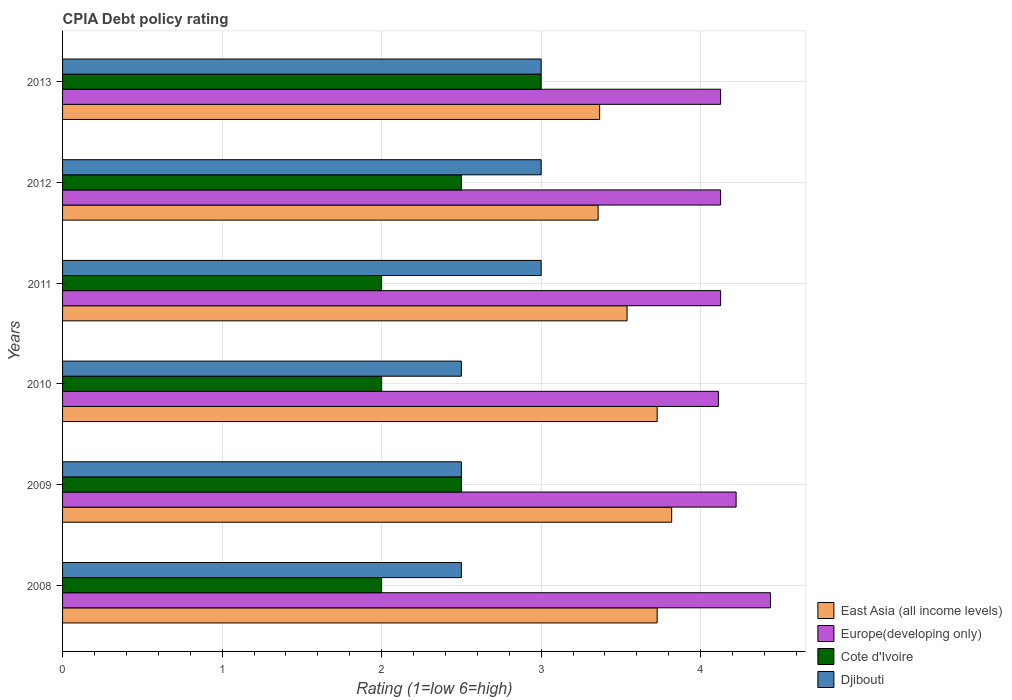How many different coloured bars are there?
Offer a very short reply. 4. Are the number of bars per tick equal to the number of legend labels?
Provide a short and direct response. Yes. How many bars are there on the 5th tick from the bottom?
Provide a short and direct response. 4. What is the label of the 5th group of bars from the top?
Offer a terse response. 2009. In how many cases, is the number of bars for a given year not equal to the number of legend labels?
Keep it short and to the point. 0. What is the CPIA rating in Europe(developing only) in 2009?
Your answer should be very brief. 4.22. Across all years, what is the maximum CPIA rating in East Asia (all income levels)?
Ensure brevity in your answer.  3.82. Across all years, what is the minimum CPIA rating in East Asia (all income levels)?
Provide a short and direct response. 3.36. In which year was the CPIA rating in Djibouti maximum?
Your answer should be very brief. 2011. What is the average CPIA rating in Europe(developing only) per year?
Offer a very short reply. 4.19. In the year 2009, what is the difference between the CPIA rating in Djibouti and CPIA rating in Europe(developing only)?
Provide a short and direct response. -1.72. In how many years, is the CPIA rating in Djibouti greater than 3.6 ?
Give a very brief answer. 0. What is the ratio of the CPIA rating in East Asia (all income levels) in 2009 to that in 2012?
Your answer should be very brief. 1.14. Is the CPIA rating in Europe(developing only) in 2008 less than that in 2013?
Your answer should be compact. No. Is the difference between the CPIA rating in Djibouti in 2012 and 2013 greater than the difference between the CPIA rating in Europe(developing only) in 2012 and 2013?
Provide a succinct answer. No. What is the difference between the highest and the second highest CPIA rating in Cote d'Ivoire?
Make the answer very short. 0.5. What is the difference between the highest and the lowest CPIA rating in East Asia (all income levels)?
Give a very brief answer. 0.46. Is the sum of the CPIA rating in Cote d'Ivoire in 2011 and 2013 greater than the maximum CPIA rating in Djibouti across all years?
Provide a succinct answer. Yes. Is it the case that in every year, the sum of the CPIA rating in Europe(developing only) and CPIA rating in East Asia (all income levels) is greater than the sum of CPIA rating in Cote d'Ivoire and CPIA rating in Djibouti?
Keep it short and to the point. No. What does the 3rd bar from the top in 2013 represents?
Your answer should be very brief. Europe(developing only). What does the 4th bar from the bottom in 2010 represents?
Your answer should be very brief. Djibouti. Are the values on the major ticks of X-axis written in scientific E-notation?
Offer a very short reply. No. Does the graph contain grids?
Offer a terse response. Yes. Where does the legend appear in the graph?
Your answer should be compact. Bottom right. How are the legend labels stacked?
Make the answer very short. Vertical. What is the title of the graph?
Your answer should be compact. CPIA Debt policy rating. Does "Mali" appear as one of the legend labels in the graph?
Provide a succinct answer. No. What is the label or title of the X-axis?
Your answer should be very brief. Rating (1=low 6=high). What is the label or title of the Y-axis?
Make the answer very short. Years. What is the Rating (1=low 6=high) in East Asia (all income levels) in 2008?
Offer a terse response. 3.73. What is the Rating (1=low 6=high) in Europe(developing only) in 2008?
Give a very brief answer. 4.44. What is the Rating (1=low 6=high) of Cote d'Ivoire in 2008?
Ensure brevity in your answer.  2. What is the Rating (1=low 6=high) of Djibouti in 2008?
Ensure brevity in your answer.  2.5. What is the Rating (1=low 6=high) of East Asia (all income levels) in 2009?
Make the answer very short. 3.82. What is the Rating (1=low 6=high) in Europe(developing only) in 2009?
Give a very brief answer. 4.22. What is the Rating (1=low 6=high) of Djibouti in 2009?
Provide a short and direct response. 2.5. What is the Rating (1=low 6=high) of East Asia (all income levels) in 2010?
Your answer should be very brief. 3.73. What is the Rating (1=low 6=high) in Europe(developing only) in 2010?
Provide a short and direct response. 4.11. What is the Rating (1=low 6=high) in East Asia (all income levels) in 2011?
Offer a very short reply. 3.54. What is the Rating (1=low 6=high) of Europe(developing only) in 2011?
Offer a terse response. 4.12. What is the Rating (1=low 6=high) in East Asia (all income levels) in 2012?
Your answer should be very brief. 3.36. What is the Rating (1=low 6=high) in Europe(developing only) in 2012?
Your answer should be compact. 4.12. What is the Rating (1=low 6=high) of East Asia (all income levels) in 2013?
Your answer should be compact. 3.37. What is the Rating (1=low 6=high) of Europe(developing only) in 2013?
Your answer should be compact. 4.12. Across all years, what is the maximum Rating (1=low 6=high) of East Asia (all income levels)?
Give a very brief answer. 3.82. Across all years, what is the maximum Rating (1=low 6=high) in Europe(developing only)?
Provide a short and direct response. 4.44. Across all years, what is the maximum Rating (1=low 6=high) in Cote d'Ivoire?
Provide a succinct answer. 3. Across all years, what is the maximum Rating (1=low 6=high) of Djibouti?
Your answer should be very brief. 3. Across all years, what is the minimum Rating (1=low 6=high) of East Asia (all income levels)?
Your answer should be compact. 3.36. Across all years, what is the minimum Rating (1=low 6=high) in Europe(developing only)?
Your answer should be very brief. 4.11. Across all years, what is the minimum Rating (1=low 6=high) of Cote d'Ivoire?
Your answer should be very brief. 2. Across all years, what is the minimum Rating (1=low 6=high) of Djibouti?
Provide a short and direct response. 2.5. What is the total Rating (1=low 6=high) in East Asia (all income levels) in the graph?
Offer a terse response. 21.54. What is the total Rating (1=low 6=high) in Europe(developing only) in the graph?
Ensure brevity in your answer.  25.15. What is the total Rating (1=low 6=high) of Djibouti in the graph?
Your response must be concise. 16.5. What is the difference between the Rating (1=low 6=high) of East Asia (all income levels) in 2008 and that in 2009?
Make the answer very short. -0.09. What is the difference between the Rating (1=low 6=high) in Europe(developing only) in 2008 and that in 2009?
Your response must be concise. 0.22. What is the difference between the Rating (1=low 6=high) of East Asia (all income levels) in 2008 and that in 2010?
Make the answer very short. 0. What is the difference between the Rating (1=low 6=high) of Europe(developing only) in 2008 and that in 2010?
Provide a short and direct response. 0.33. What is the difference between the Rating (1=low 6=high) in Cote d'Ivoire in 2008 and that in 2010?
Keep it short and to the point. 0. What is the difference between the Rating (1=low 6=high) in East Asia (all income levels) in 2008 and that in 2011?
Keep it short and to the point. 0.19. What is the difference between the Rating (1=low 6=high) in Europe(developing only) in 2008 and that in 2011?
Offer a very short reply. 0.31. What is the difference between the Rating (1=low 6=high) in Djibouti in 2008 and that in 2011?
Provide a succinct answer. -0.5. What is the difference between the Rating (1=low 6=high) in East Asia (all income levels) in 2008 and that in 2012?
Make the answer very short. 0.37. What is the difference between the Rating (1=low 6=high) of Europe(developing only) in 2008 and that in 2012?
Make the answer very short. 0.31. What is the difference between the Rating (1=low 6=high) of Cote d'Ivoire in 2008 and that in 2012?
Ensure brevity in your answer.  -0.5. What is the difference between the Rating (1=low 6=high) of Djibouti in 2008 and that in 2012?
Ensure brevity in your answer.  -0.5. What is the difference between the Rating (1=low 6=high) of East Asia (all income levels) in 2008 and that in 2013?
Give a very brief answer. 0.36. What is the difference between the Rating (1=low 6=high) in Europe(developing only) in 2008 and that in 2013?
Your answer should be compact. 0.31. What is the difference between the Rating (1=low 6=high) in East Asia (all income levels) in 2009 and that in 2010?
Offer a terse response. 0.09. What is the difference between the Rating (1=low 6=high) of Europe(developing only) in 2009 and that in 2010?
Offer a terse response. 0.11. What is the difference between the Rating (1=low 6=high) of Cote d'Ivoire in 2009 and that in 2010?
Your answer should be very brief. 0.5. What is the difference between the Rating (1=low 6=high) of East Asia (all income levels) in 2009 and that in 2011?
Ensure brevity in your answer.  0.28. What is the difference between the Rating (1=low 6=high) in Europe(developing only) in 2009 and that in 2011?
Ensure brevity in your answer.  0.1. What is the difference between the Rating (1=low 6=high) of East Asia (all income levels) in 2009 and that in 2012?
Provide a succinct answer. 0.46. What is the difference between the Rating (1=low 6=high) in Europe(developing only) in 2009 and that in 2012?
Ensure brevity in your answer.  0.1. What is the difference between the Rating (1=low 6=high) in Cote d'Ivoire in 2009 and that in 2012?
Offer a very short reply. 0. What is the difference between the Rating (1=low 6=high) in East Asia (all income levels) in 2009 and that in 2013?
Give a very brief answer. 0.45. What is the difference between the Rating (1=low 6=high) in Europe(developing only) in 2009 and that in 2013?
Provide a short and direct response. 0.1. What is the difference between the Rating (1=low 6=high) of East Asia (all income levels) in 2010 and that in 2011?
Make the answer very short. 0.19. What is the difference between the Rating (1=low 6=high) of Europe(developing only) in 2010 and that in 2011?
Provide a succinct answer. -0.01. What is the difference between the Rating (1=low 6=high) of Cote d'Ivoire in 2010 and that in 2011?
Keep it short and to the point. 0. What is the difference between the Rating (1=low 6=high) of Djibouti in 2010 and that in 2011?
Your answer should be very brief. -0.5. What is the difference between the Rating (1=low 6=high) of East Asia (all income levels) in 2010 and that in 2012?
Your response must be concise. 0.37. What is the difference between the Rating (1=low 6=high) of Europe(developing only) in 2010 and that in 2012?
Your answer should be very brief. -0.01. What is the difference between the Rating (1=low 6=high) in Cote d'Ivoire in 2010 and that in 2012?
Provide a short and direct response. -0.5. What is the difference between the Rating (1=low 6=high) of Djibouti in 2010 and that in 2012?
Ensure brevity in your answer.  -0.5. What is the difference between the Rating (1=low 6=high) in East Asia (all income levels) in 2010 and that in 2013?
Offer a terse response. 0.36. What is the difference between the Rating (1=low 6=high) in Europe(developing only) in 2010 and that in 2013?
Ensure brevity in your answer.  -0.01. What is the difference between the Rating (1=low 6=high) in Cote d'Ivoire in 2010 and that in 2013?
Offer a terse response. -1. What is the difference between the Rating (1=low 6=high) of East Asia (all income levels) in 2011 and that in 2012?
Provide a succinct answer. 0.18. What is the difference between the Rating (1=low 6=high) of Djibouti in 2011 and that in 2012?
Give a very brief answer. 0. What is the difference between the Rating (1=low 6=high) of East Asia (all income levels) in 2011 and that in 2013?
Offer a terse response. 0.17. What is the difference between the Rating (1=low 6=high) of Europe(developing only) in 2011 and that in 2013?
Offer a very short reply. 0. What is the difference between the Rating (1=low 6=high) of East Asia (all income levels) in 2012 and that in 2013?
Offer a terse response. -0.01. What is the difference between the Rating (1=low 6=high) in East Asia (all income levels) in 2008 and the Rating (1=low 6=high) in Europe(developing only) in 2009?
Provide a succinct answer. -0.49. What is the difference between the Rating (1=low 6=high) in East Asia (all income levels) in 2008 and the Rating (1=low 6=high) in Cote d'Ivoire in 2009?
Offer a terse response. 1.23. What is the difference between the Rating (1=low 6=high) in East Asia (all income levels) in 2008 and the Rating (1=low 6=high) in Djibouti in 2009?
Give a very brief answer. 1.23. What is the difference between the Rating (1=low 6=high) in Europe(developing only) in 2008 and the Rating (1=low 6=high) in Cote d'Ivoire in 2009?
Your answer should be very brief. 1.94. What is the difference between the Rating (1=low 6=high) of Europe(developing only) in 2008 and the Rating (1=low 6=high) of Djibouti in 2009?
Keep it short and to the point. 1.94. What is the difference between the Rating (1=low 6=high) of East Asia (all income levels) in 2008 and the Rating (1=low 6=high) of Europe(developing only) in 2010?
Offer a very short reply. -0.38. What is the difference between the Rating (1=low 6=high) in East Asia (all income levels) in 2008 and the Rating (1=low 6=high) in Cote d'Ivoire in 2010?
Keep it short and to the point. 1.73. What is the difference between the Rating (1=low 6=high) of East Asia (all income levels) in 2008 and the Rating (1=low 6=high) of Djibouti in 2010?
Provide a short and direct response. 1.23. What is the difference between the Rating (1=low 6=high) of Europe(developing only) in 2008 and the Rating (1=low 6=high) of Cote d'Ivoire in 2010?
Your response must be concise. 2.44. What is the difference between the Rating (1=low 6=high) of Europe(developing only) in 2008 and the Rating (1=low 6=high) of Djibouti in 2010?
Provide a succinct answer. 1.94. What is the difference between the Rating (1=low 6=high) in Cote d'Ivoire in 2008 and the Rating (1=low 6=high) in Djibouti in 2010?
Your response must be concise. -0.5. What is the difference between the Rating (1=low 6=high) of East Asia (all income levels) in 2008 and the Rating (1=low 6=high) of Europe(developing only) in 2011?
Your answer should be very brief. -0.4. What is the difference between the Rating (1=low 6=high) in East Asia (all income levels) in 2008 and the Rating (1=low 6=high) in Cote d'Ivoire in 2011?
Ensure brevity in your answer.  1.73. What is the difference between the Rating (1=low 6=high) in East Asia (all income levels) in 2008 and the Rating (1=low 6=high) in Djibouti in 2011?
Offer a terse response. 0.73. What is the difference between the Rating (1=low 6=high) of Europe(developing only) in 2008 and the Rating (1=low 6=high) of Cote d'Ivoire in 2011?
Give a very brief answer. 2.44. What is the difference between the Rating (1=low 6=high) of Europe(developing only) in 2008 and the Rating (1=low 6=high) of Djibouti in 2011?
Give a very brief answer. 1.44. What is the difference between the Rating (1=low 6=high) of Cote d'Ivoire in 2008 and the Rating (1=low 6=high) of Djibouti in 2011?
Give a very brief answer. -1. What is the difference between the Rating (1=low 6=high) of East Asia (all income levels) in 2008 and the Rating (1=low 6=high) of Europe(developing only) in 2012?
Provide a short and direct response. -0.4. What is the difference between the Rating (1=low 6=high) in East Asia (all income levels) in 2008 and the Rating (1=low 6=high) in Cote d'Ivoire in 2012?
Keep it short and to the point. 1.23. What is the difference between the Rating (1=low 6=high) of East Asia (all income levels) in 2008 and the Rating (1=low 6=high) of Djibouti in 2012?
Your response must be concise. 0.73. What is the difference between the Rating (1=low 6=high) of Europe(developing only) in 2008 and the Rating (1=low 6=high) of Cote d'Ivoire in 2012?
Your answer should be very brief. 1.94. What is the difference between the Rating (1=low 6=high) of Europe(developing only) in 2008 and the Rating (1=low 6=high) of Djibouti in 2012?
Make the answer very short. 1.44. What is the difference between the Rating (1=low 6=high) in Cote d'Ivoire in 2008 and the Rating (1=low 6=high) in Djibouti in 2012?
Your answer should be compact. -1. What is the difference between the Rating (1=low 6=high) in East Asia (all income levels) in 2008 and the Rating (1=low 6=high) in Europe(developing only) in 2013?
Keep it short and to the point. -0.4. What is the difference between the Rating (1=low 6=high) of East Asia (all income levels) in 2008 and the Rating (1=low 6=high) of Cote d'Ivoire in 2013?
Your response must be concise. 0.73. What is the difference between the Rating (1=low 6=high) of East Asia (all income levels) in 2008 and the Rating (1=low 6=high) of Djibouti in 2013?
Your response must be concise. 0.73. What is the difference between the Rating (1=low 6=high) in Europe(developing only) in 2008 and the Rating (1=low 6=high) in Cote d'Ivoire in 2013?
Make the answer very short. 1.44. What is the difference between the Rating (1=low 6=high) in Europe(developing only) in 2008 and the Rating (1=low 6=high) in Djibouti in 2013?
Your answer should be compact. 1.44. What is the difference between the Rating (1=low 6=high) of Cote d'Ivoire in 2008 and the Rating (1=low 6=high) of Djibouti in 2013?
Provide a short and direct response. -1. What is the difference between the Rating (1=low 6=high) of East Asia (all income levels) in 2009 and the Rating (1=low 6=high) of Europe(developing only) in 2010?
Offer a very short reply. -0.29. What is the difference between the Rating (1=low 6=high) of East Asia (all income levels) in 2009 and the Rating (1=low 6=high) of Cote d'Ivoire in 2010?
Offer a terse response. 1.82. What is the difference between the Rating (1=low 6=high) of East Asia (all income levels) in 2009 and the Rating (1=low 6=high) of Djibouti in 2010?
Ensure brevity in your answer.  1.32. What is the difference between the Rating (1=low 6=high) in Europe(developing only) in 2009 and the Rating (1=low 6=high) in Cote d'Ivoire in 2010?
Offer a very short reply. 2.22. What is the difference between the Rating (1=low 6=high) in Europe(developing only) in 2009 and the Rating (1=low 6=high) in Djibouti in 2010?
Provide a short and direct response. 1.72. What is the difference between the Rating (1=low 6=high) in East Asia (all income levels) in 2009 and the Rating (1=low 6=high) in Europe(developing only) in 2011?
Give a very brief answer. -0.31. What is the difference between the Rating (1=low 6=high) of East Asia (all income levels) in 2009 and the Rating (1=low 6=high) of Cote d'Ivoire in 2011?
Your answer should be very brief. 1.82. What is the difference between the Rating (1=low 6=high) in East Asia (all income levels) in 2009 and the Rating (1=low 6=high) in Djibouti in 2011?
Offer a terse response. 0.82. What is the difference between the Rating (1=low 6=high) in Europe(developing only) in 2009 and the Rating (1=low 6=high) in Cote d'Ivoire in 2011?
Provide a short and direct response. 2.22. What is the difference between the Rating (1=low 6=high) in Europe(developing only) in 2009 and the Rating (1=low 6=high) in Djibouti in 2011?
Provide a short and direct response. 1.22. What is the difference between the Rating (1=low 6=high) in East Asia (all income levels) in 2009 and the Rating (1=low 6=high) in Europe(developing only) in 2012?
Provide a succinct answer. -0.31. What is the difference between the Rating (1=low 6=high) in East Asia (all income levels) in 2009 and the Rating (1=low 6=high) in Cote d'Ivoire in 2012?
Keep it short and to the point. 1.32. What is the difference between the Rating (1=low 6=high) of East Asia (all income levels) in 2009 and the Rating (1=low 6=high) of Djibouti in 2012?
Make the answer very short. 0.82. What is the difference between the Rating (1=low 6=high) in Europe(developing only) in 2009 and the Rating (1=low 6=high) in Cote d'Ivoire in 2012?
Make the answer very short. 1.72. What is the difference between the Rating (1=low 6=high) in Europe(developing only) in 2009 and the Rating (1=low 6=high) in Djibouti in 2012?
Provide a short and direct response. 1.22. What is the difference between the Rating (1=low 6=high) in East Asia (all income levels) in 2009 and the Rating (1=low 6=high) in Europe(developing only) in 2013?
Offer a very short reply. -0.31. What is the difference between the Rating (1=low 6=high) in East Asia (all income levels) in 2009 and the Rating (1=low 6=high) in Cote d'Ivoire in 2013?
Your answer should be compact. 0.82. What is the difference between the Rating (1=low 6=high) of East Asia (all income levels) in 2009 and the Rating (1=low 6=high) of Djibouti in 2013?
Your answer should be very brief. 0.82. What is the difference between the Rating (1=low 6=high) of Europe(developing only) in 2009 and the Rating (1=low 6=high) of Cote d'Ivoire in 2013?
Your response must be concise. 1.22. What is the difference between the Rating (1=low 6=high) of Europe(developing only) in 2009 and the Rating (1=low 6=high) of Djibouti in 2013?
Offer a very short reply. 1.22. What is the difference between the Rating (1=low 6=high) of East Asia (all income levels) in 2010 and the Rating (1=low 6=high) of Europe(developing only) in 2011?
Give a very brief answer. -0.4. What is the difference between the Rating (1=low 6=high) of East Asia (all income levels) in 2010 and the Rating (1=low 6=high) of Cote d'Ivoire in 2011?
Provide a short and direct response. 1.73. What is the difference between the Rating (1=low 6=high) of East Asia (all income levels) in 2010 and the Rating (1=low 6=high) of Djibouti in 2011?
Your answer should be compact. 0.73. What is the difference between the Rating (1=low 6=high) in Europe(developing only) in 2010 and the Rating (1=low 6=high) in Cote d'Ivoire in 2011?
Make the answer very short. 2.11. What is the difference between the Rating (1=low 6=high) of Cote d'Ivoire in 2010 and the Rating (1=low 6=high) of Djibouti in 2011?
Your response must be concise. -1. What is the difference between the Rating (1=low 6=high) in East Asia (all income levels) in 2010 and the Rating (1=low 6=high) in Europe(developing only) in 2012?
Make the answer very short. -0.4. What is the difference between the Rating (1=low 6=high) of East Asia (all income levels) in 2010 and the Rating (1=low 6=high) of Cote d'Ivoire in 2012?
Offer a very short reply. 1.23. What is the difference between the Rating (1=low 6=high) in East Asia (all income levels) in 2010 and the Rating (1=low 6=high) in Djibouti in 2012?
Your response must be concise. 0.73. What is the difference between the Rating (1=low 6=high) of Europe(developing only) in 2010 and the Rating (1=low 6=high) of Cote d'Ivoire in 2012?
Your answer should be very brief. 1.61. What is the difference between the Rating (1=low 6=high) in East Asia (all income levels) in 2010 and the Rating (1=low 6=high) in Europe(developing only) in 2013?
Offer a very short reply. -0.4. What is the difference between the Rating (1=low 6=high) of East Asia (all income levels) in 2010 and the Rating (1=low 6=high) of Cote d'Ivoire in 2013?
Offer a very short reply. 0.73. What is the difference between the Rating (1=low 6=high) in East Asia (all income levels) in 2010 and the Rating (1=low 6=high) in Djibouti in 2013?
Make the answer very short. 0.73. What is the difference between the Rating (1=low 6=high) of Cote d'Ivoire in 2010 and the Rating (1=low 6=high) of Djibouti in 2013?
Make the answer very short. -1. What is the difference between the Rating (1=low 6=high) in East Asia (all income levels) in 2011 and the Rating (1=low 6=high) in Europe(developing only) in 2012?
Offer a very short reply. -0.59. What is the difference between the Rating (1=low 6=high) of East Asia (all income levels) in 2011 and the Rating (1=low 6=high) of Cote d'Ivoire in 2012?
Keep it short and to the point. 1.04. What is the difference between the Rating (1=low 6=high) in East Asia (all income levels) in 2011 and the Rating (1=low 6=high) in Djibouti in 2012?
Your answer should be compact. 0.54. What is the difference between the Rating (1=low 6=high) of Europe(developing only) in 2011 and the Rating (1=low 6=high) of Cote d'Ivoire in 2012?
Your answer should be compact. 1.62. What is the difference between the Rating (1=low 6=high) of Europe(developing only) in 2011 and the Rating (1=low 6=high) of Djibouti in 2012?
Offer a very short reply. 1.12. What is the difference between the Rating (1=low 6=high) of East Asia (all income levels) in 2011 and the Rating (1=low 6=high) of Europe(developing only) in 2013?
Keep it short and to the point. -0.59. What is the difference between the Rating (1=low 6=high) in East Asia (all income levels) in 2011 and the Rating (1=low 6=high) in Cote d'Ivoire in 2013?
Keep it short and to the point. 0.54. What is the difference between the Rating (1=low 6=high) of East Asia (all income levels) in 2011 and the Rating (1=low 6=high) of Djibouti in 2013?
Offer a very short reply. 0.54. What is the difference between the Rating (1=low 6=high) of East Asia (all income levels) in 2012 and the Rating (1=low 6=high) of Europe(developing only) in 2013?
Provide a succinct answer. -0.77. What is the difference between the Rating (1=low 6=high) in East Asia (all income levels) in 2012 and the Rating (1=low 6=high) in Cote d'Ivoire in 2013?
Provide a short and direct response. 0.36. What is the difference between the Rating (1=low 6=high) of East Asia (all income levels) in 2012 and the Rating (1=low 6=high) of Djibouti in 2013?
Your answer should be very brief. 0.36. What is the difference between the Rating (1=low 6=high) of Europe(developing only) in 2012 and the Rating (1=low 6=high) of Djibouti in 2013?
Your answer should be very brief. 1.12. What is the difference between the Rating (1=low 6=high) of Cote d'Ivoire in 2012 and the Rating (1=low 6=high) of Djibouti in 2013?
Provide a succinct answer. -0.5. What is the average Rating (1=low 6=high) of East Asia (all income levels) per year?
Ensure brevity in your answer.  3.59. What is the average Rating (1=low 6=high) in Europe(developing only) per year?
Give a very brief answer. 4.19. What is the average Rating (1=low 6=high) of Cote d'Ivoire per year?
Your answer should be compact. 2.33. What is the average Rating (1=low 6=high) of Djibouti per year?
Give a very brief answer. 2.75. In the year 2008, what is the difference between the Rating (1=low 6=high) in East Asia (all income levels) and Rating (1=low 6=high) in Europe(developing only)?
Provide a short and direct response. -0.71. In the year 2008, what is the difference between the Rating (1=low 6=high) in East Asia (all income levels) and Rating (1=low 6=high) in Cote d'Ivoire?
Offer a terse response. 1.73. In the year 2008, what is the difference between the Rating (1=low 6=high) in East Asia (all income levels) and Rating (1=low 6=high) in Djibouti?
Your answer should be compact. 1.23. In the year 2008, what is the difference between the Rating (1=low 6=high) of Europe(developing only) and Rating (1=low 6=high) of Cote d'Ivoire?
Offer a terse response. 2.44. In the year 2008, what is the difference between the Rating (1=low 6=high) of Europe(developing only) and Rating (1=low 6=high) of Djibouti?
Offer a very short reply. 1.94. In the year 2008, what is the difference between the Rating (1=low 6=high) of Cote d'Ivoire and Rating (1=low 6=high) of Djibouti?
Your answer should be very brief. -0.5. In the year 2009, what is the difference between the Rating (1=low 6=high) in East Asia (all income levels) and Rating (1=low 6=high) in Europe(developing only)?
Make the answer very short. -0.4. In the year 2009, what is the difference between the Rating (1=low 6=high) of East Asia (all income levels) and Rating (1=low 6=high) of Cote d'Ivoire?
Offer a very short reply. 1.32. In the year 2009, what is the difference between the Rating (1=low 6=high) in East Asia (all income levels) and Rating (1=low 6=high) in Djibouti?
Make the answer very short. 1.32. In the year 2009, what is the difference between the Rating (1=low 6=high) of Europe(developing only) and Rating (1=low 6=high) of Cote d'Ivoire?
Make the answer very short. 1.72. In the year 2009, what is the difference between the Rating (1=low 6=high) in Europe(developing only) and Rating (1=low 6=high) in Djibouti?
Make the answer very short. 1.72. In the year 2009, what is the difference between the Rating (1=low 6=high) in Cote d'Ivoire and Rating (1=low 6=high) in Djibouti?
Offer a very short reply. 0. In the year 2010, what is the difference between the Rating (1=low 6=high) of East Asia (all income levels) and Rating (1=low 6=high) of Europe(developing only)?
Provide a succinct answer. -0.38. In the year 2010, what is the difference between the Rating (1=low 6=high) in East Asia (all income levels) and Rating (1=low 6=high) in Cote d'Ivoire?
Ensure brevity in your answer.  1.73. In the year 2010, what is the difference between the Rating (1=low 6=high) of East Asia (all income levels) and Rating (1=low 6=high) of Djibouti?
Make the answer very short. 1.23. In the year 2010, what is the difference between the Rating (1=low 6=high) in Europe(developing only) and Rating (1=low 6=high) in Cote d'Ivoire?
Provide a succinct answer. 2.11. In the year 2010, what is the difference between the Rating (1=low 6=high) of Europe(developing only) and Rating (1=low 6=high) of Djibouti?
Your answer should be compact. 1.61. In the year 2011, what is the difference between the Rating (1=low 6=high) of East Asia (all income levels) and Rating (1=low 6=high) of Europe(developing only)?
Your answer should be very brief. -0.59. In the year 2011, what is the difference between the Rating (1=low 6=high) of East Asia (all income levels) and Rating (1=low 6=high) of Cote d'Ivoire?
Your answer should be compact. 1.54. In the year 2011, what is the difference between the Rating (1=low 6=high) of East Asia (all income levels) and Rating (1=low 6=high) of Djibouti?
Offer a very short reply. 0.54. In the year 2011, what is the difference between the Rating (1=low 6=high) in Europe(developing only) and Rating (1=low 6=high) in Cote d'Ivoire?
Ensure brevity in your answer.  2.12. In the year 2011, what is the difference between the Rating (1=low 6=high) of Europe(developing only) and Rating (1=low 6=high) of Djibouti?
Offer a very short reply. 1.12. In the year 2011, what is the difference between the Rating (1=low 6=high) in Cote d'Ivoire and Rating (1=low 6=high) in Djibouti?
Your answer should be compact. -1. In the year 2012, what is the difference between the Rating (1=low 6=high) of East Asia (all income levels) and Rating (1=low 6=high) of Europe(developing only)?
Ensure brevity in your answer.  -0.77. In the year 2012, what is the difference between the Rating (1=low 6=high) in East Asia (all income levels) and Rating (1=low 6=high) in Cote d'Ivoire?
Give a very brief answer. 0.86. In the year 2012, what is the difference between the Rating (1=low 6=high) in East Asia (all income levels) and Rating (1=low 6=high) in Djibouti?
Your response must be concise. 0.36. In the year 2012, what is the difference between the Rating (1=low 6=high) in Europe(developing only) and Rating (1=low 6=high) in Cote d'Ivoire?
Keep it short and to the point. 1.62. In the year 2012, what is the difference between the Rating (1=low 6=high) in Cote d'Ivoire and Rating (1=low 6=high) in Djibouti?
Your response must be concise. -0.5. In the year 2013, what is the difference between the Rating (1=low 6=high) in East Asia (all income levels) and Rating (1=low 6=high) in Europe(developing only)?
Ensure brevity in your answer.  -0.76. In the year 2013, what is the difference between the Rating (1=low 6=high) in East Asia (all income levels) and Rating (1=low 6=high) in Cote d'Ivoire?
Offer a very short reply. 0.37. In the year 2013, what is the difference between the Rating (1=low 6=high) in East Asia (all income levels) and Rating (1=low 6=high) in Djibouti?
Make the answer very short. 0.37. In the year 2013, what is the difference between the Rating (1=low 6=high) of Europe(developing only) and Rating (1=low 6=high) of Djibouti?
Your answer should be compact. 1.12. What is the ratio of the Rating (1=low 6=high) of East Asia (all income levels) in 2008 to that in 2009?
Keep it short and to the point. 0.98. What is the ratio of the Rating (1=low 6=high) of Europe(developing only) in 2008 to that in 2009?
Provide a succinct answer. 1.05. What is the ratio of the Rating (1=low 6=high) of Djibouti in 2008 to that in 2009?
Keep it short and to the point. 1. What is the ratio of the Rating (1=low 6=high) of Europe(developing only) in 2008 to that in 2010?
Offer a very short reply. 1.08. What is the ratio of the Rating (1=low 6=high) in Cote d'Ivoire in 2008 to that in 2010?
Give a very brief answer. 1. What is the ratio of the Rating (1=low 6=high) of Djibouti in 2008 to that in 2010?
Your answer should be compact. 1. What is the ratio of the Rating (1=low 6=high) in East Asia (all income levels) in 2008 to that in 2011?
Provide a short and direct response. 1.05. What is the ratio of the Rating (1=low 6=high) in Europe(developing only) in 2008 to that in 2011?
Offer a very short reply. 1.08. What is the ratio of the Rating (1=low 6=high) in Djibouti in 2008 to that in 2011?
Your response must be concise. 0.83. What is the ratio of the Rating (1=low 6=high) in East Asia (all income levels) in 2008 to that in 2012?
Offer a very short reply. 1.11. What is the ratio of the Rating (1=low 6=high) in Europe(developing only) in 2008 to that in 2012?
Keep it short and to the point. 1.08. What is the ratio of the Rating (1=low 6=high) of Cote d'Ivoire in 2008 to that in 2012?
Make the answer very short. 0.8. What is the ratio of the Rating (1=low 6=high) of East Asia (all income levels) in 2008 to that in 2013?
Offer a terse response. 1.11. What is the ratio of the Rating (1=low 6=high) in Europe(developing only) in 2008 to that in 2013?
Give a very brief answer. 1.08. What is the ratio of the Rating (1=low 6=high) in Djibouti in 2008 to that in 2013?
Keep it short and to the point. 0.83. What is the ratio of the Rating (1=low 6=high) in East Asia (all income levels) in 2009 to that in 2010?
Make the answer very short. 1.02. What is the ratio of the Rating (1=low 6=high) of Europe(developing only) in 2009 to that in 2010?
Give a very brief answer. 1.03. What is the ratio of the Rating (1=low 6=high) of Djibouti in 2009 to that in 2010?
Your answer should be compact. 1. What is the ratio of the Rating (1=low 6=high) of East Asia (all income levels) in 2009 to that in 2011?
Ensure brevity in your answer.  1.08. What is the ratio of the Rating (1=low 6=high) in Europe(developing only) in 2009 to that in 2011?
Your response must be concise. 1.02. What is the ratio of the Rating (1=low 6=high) in Cote d'Ivoire in 2009 to that in 2011?
Give a very brief answer. 1.25. What is the ratio of the Rating (1=low 6=high) of Djibouti in 2009 to that in 2011?
Your answer should be compact. 0.83. What is the ratio of the Rating (1=low 6=high) of East Asia (all income levels) in 2009 to that in 2012?
Your answer should be very brief. 1.14. What is the ratio of the Rating (1=low 6=high) in Europe(developing only) in 2009 to that in 2012?
Offer a terse response. 1.02. What is the ratio of the Rating (1=low 6=high) in Djibouti in 2009 to that in 2012?
Your answer should be compact. 0.83. What is the ratio of the Rating (1=low 6=high) of East Asia (all income levels) in 2009 to that in 2013?
Your response must be concise. 1.13. What is the ratio of the Rating (1=low 6=high) of Europe(developing only) in 2009 to that in 2013?
Your answer should be compact. 1.02. What is the ratio of the Rating (1=low 6=high) of Djibouti in 2009 to that in 2013?
Ensure brevity in your answer.  0.83. What is the ratio of the Rating (1=low 6=high) of East Asia (all income levels) in 2010 to that in 2011?
Offer a very short reply. 1.05. What is the ratio of the Rating (1=low 6=high) of East Asia (all income levels) in 2010 to that in 2012?
Make the answer very short. 1.11. What is the ratio of the Rating (1=low 6=high) of Europe(developing only) in 2010 to that in 2012?
Your answer should be very brief. 1. What is the ratio of the Rating (1=low 6=high) in Djibouti in 2010 to that in 2012?
Make the answer very short. 0.83. What is the ratio of the Rating (1=low 6=high) of East Asia (all income levels) in 2010 to that in 2013?
Ensure brevity in your answer.  1.11. What is the ratio of the Rating (1=low 6=high) in Europe(developing only) in 2010 to that in 2013?
Your answer should be very brief. 1. What is the ratio of the Rating (1=low 6=high) of Djibouti in 2010 to that in 2013?
Give a very brief answer. 0.83. What is the ratio of the Rating (1=low 6=high) of East Asia (all income levels) in 2011 to that in 2012?
Your answer should be very brief. 1.05. What is the ratio of the Rating (1=low 6=high) of Europe(developing only) in 2011 to that in 2012?
Provide a short and direct response. 1. What is the ratio of the Rating (1=low 6=high) of Djibouti in 2011 to that in 2012?
Make the answer very short. 1. What is the ratio of the Rating (1=low 6=high) in East Asia (all income levels) in 2011 to that in 2013?
Ensure brevity in your answer.  1.05. What is the ratio of the Rating (1=low 6=high) in Europe(developing only) in 2011 to that in 2013?
Your answer should be very brief. 1. What is the ratio of the Rating (1=low 6=high) of Europe(developing only) in 2012 to that in 2013?
Provide a short and direct response. 1. What is the ratio of the Rating (1=low 6=high) in Djibouti in 2012 to that in 2013?
Keep it short and to the point. 1. What is the difference between the highest and the second highest Rating (1=low 6=high) in East Asia (all income levels)?
Your answer should be compact. 0.09. What is the difference between the highest and the second highest Rating (1=low 6=high) of Europe(developing only)?
Your answer should be very brief. 0.22. What is the difference between the highest and the lowest Rating (1=low 6=high) of East Asia (all income levels)?
Your answer should be compact. 0.46. What is the difference between the highest and the lowest Rating (1=low 6=high) in Europe(developing only)?
Keep it short and to the point. 0.33. What is the difference between the highest and the lowest Rating (1=low 6=high) of Cote d'Ivoire?
Give a very brief answer. 1. 